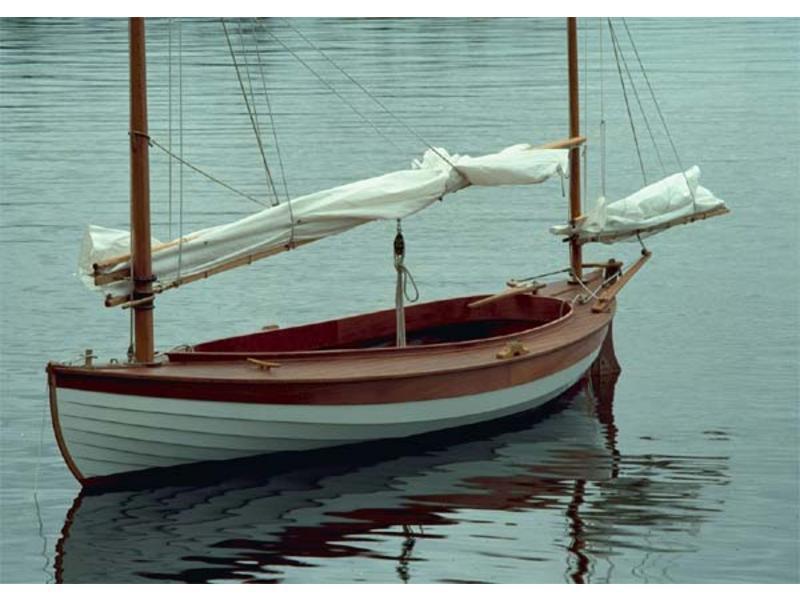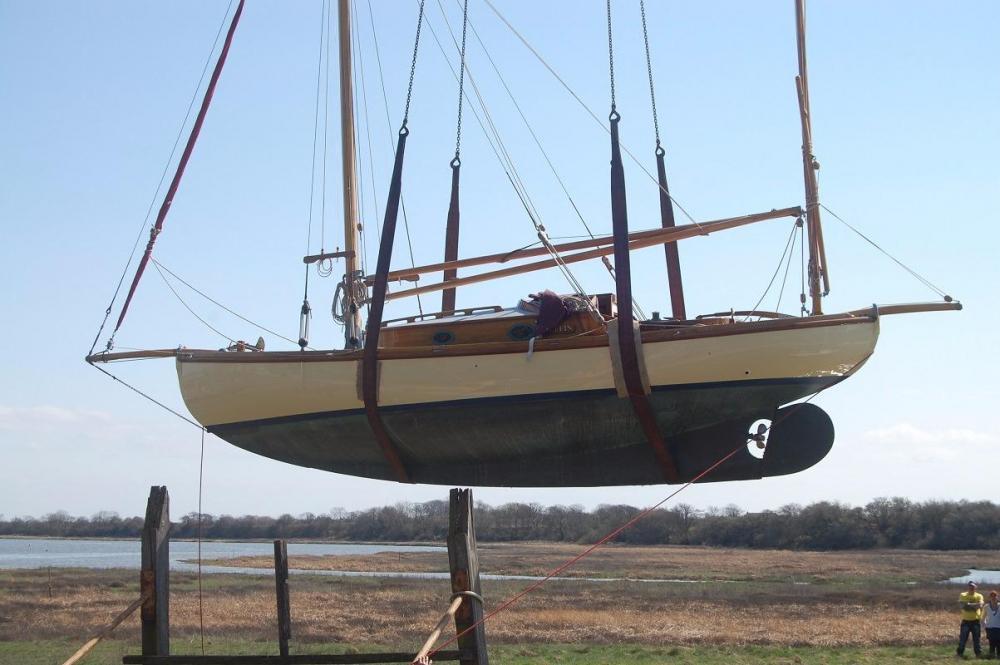The first image is the image on the left, the second image is the image on the right. Assess this claim about the two images: "The boat in the right image has its sails up.". Correct or not? Answer yes or no. No. 